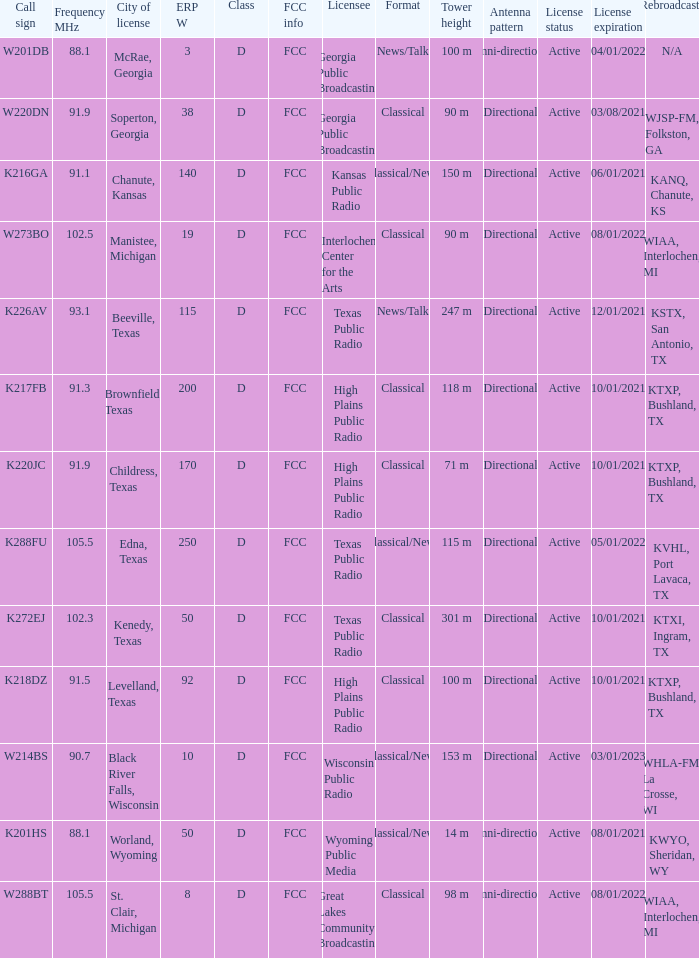Could you parse the entire table? {'header': ['Call sign', 'Frequency MHz', 'City of license', 'ERP W', 'Class', 'FCC info', 'Licensee', 'Format', 'Tower height', 'Antenna pattern', 'License status', 'License expiration', 'Rebroadcasts'], 'rows': [['W201DB', '88.1', 'McRae, Georgia', '3', 'D', 'FCC', 'Georgia Public Broadcasting', 'News/Talk', '100 m', 'Omni-directional', 'Active', '04/01/2022', 'N/A'], ['W220DN', '91.9', 'Soperton, Georgia', '38', 'D', 'FCC', 'Georgia Public Broadcasting', 'Classical', '90 m', 'Directional', 'Active', '03/08/2021', 'WJSP-FM, Folkston, GA'], ['K216GA', '91.1', 'Chanute, Kansas', '140', 'D', 'FCC', 'Kansas Public Radio', 'Classical/News', '150 m', 'Directional', 'Active', '06/01/2021', 'KANQ, Chanute, KS'], ['W273BO', '102.5', 'Manistee, Michigan', '19', 'D', 'FCC', 'Interlochen Center for the Arts', 'Classical', '90 m', 'Directional', 'Active', '08/01/2022', 'WIAA, Interlochen, MI'], ['K226AV', '93.1', 'Beeville, Texas', '115', 'D', 'FCC', 'Texas Public Radio', 'News/Talk', '247 m', 'Directional', 'Active', '12/01/2021', 'KSTX, San Antonio, TX'], ['K217FB', '91.3', 'Brownfield, Texas', '200', 'D', 'FCC', 'High Plains Public Radio', 'Classical', '118 m', 'Directional', 'Active', '10/01/2021', 'KTXP, Bushland, TX'], ['K220JC', '91.9', 'Childress, Texas', '170', 'D', 'FCC', 'High Plains Public Radio', 'Classical', '71 m', 'Directional', 'Active', '10/01/2021', 'KTXP, Bushland, TX'], ['K288FU', '105.5', 'Edna, Texas', '250', 'D', 'FCC', 'Texas Public Radio', 'Classical/News', '115 m', 'Directional', 'Active', '05/01/2022', 'KVHL, Port Lavaca, TX'], ['K272EJ', '102.3', 'Kenedy, Texas', '50', 'D', 'FCC', 'Texas Public Radio', 'Classical', '301 m', 'Directional', 'Active', '10/01/2021', 'KTXI, Ingram, TX'], ['K218DZ', '91.5', 'Levelland, Texas', '92', 'D', 'FCC', 'High Plains Public Radio', 'Classical', '100 m', 'Directional', 'Active', '10/01/2021', 'KTXP, Bushland, TX'], ['W214BS', '90.7', 'Black River Falls, Wisconsin', '10', 'D', 'FCC', 'Wisconsin Public Radio', 'Classical/News', '153 m', 'Directional', 'Active', '03/01/2023', 'WHLA-FM, La Crosse, WI'], ['K201HS', '88.1', 'Worland, Wyoming', '50', 'D', 'FCC', 'Wyoming Public Media', 'Classical/News', '14 m', 'Omni-directional', 'Active', '08/01/2021', 'KWYO, Sheridan, WY'], ['W288BT', '105.5', 'St. Clair, Michigan', '8', 'D', 'FCC', 'Great Lakes Community Broadcasting', 'Classical', '98 m', 'Omni-directional', 'Active', '08/01/2022', 'WIAA, Interlochen, MI']]} What is City of License, when Frequency MHz is less than 102.5? McRae, Georgia, Soperton, Georgia, Chanute, Kansas, Beeville, Texas, Brownfield, Texas, Childress, Texas, Kenedy, Texas, Levelland, Texas, Black River Falls, Wisconsin, Worland, Wyoming. 